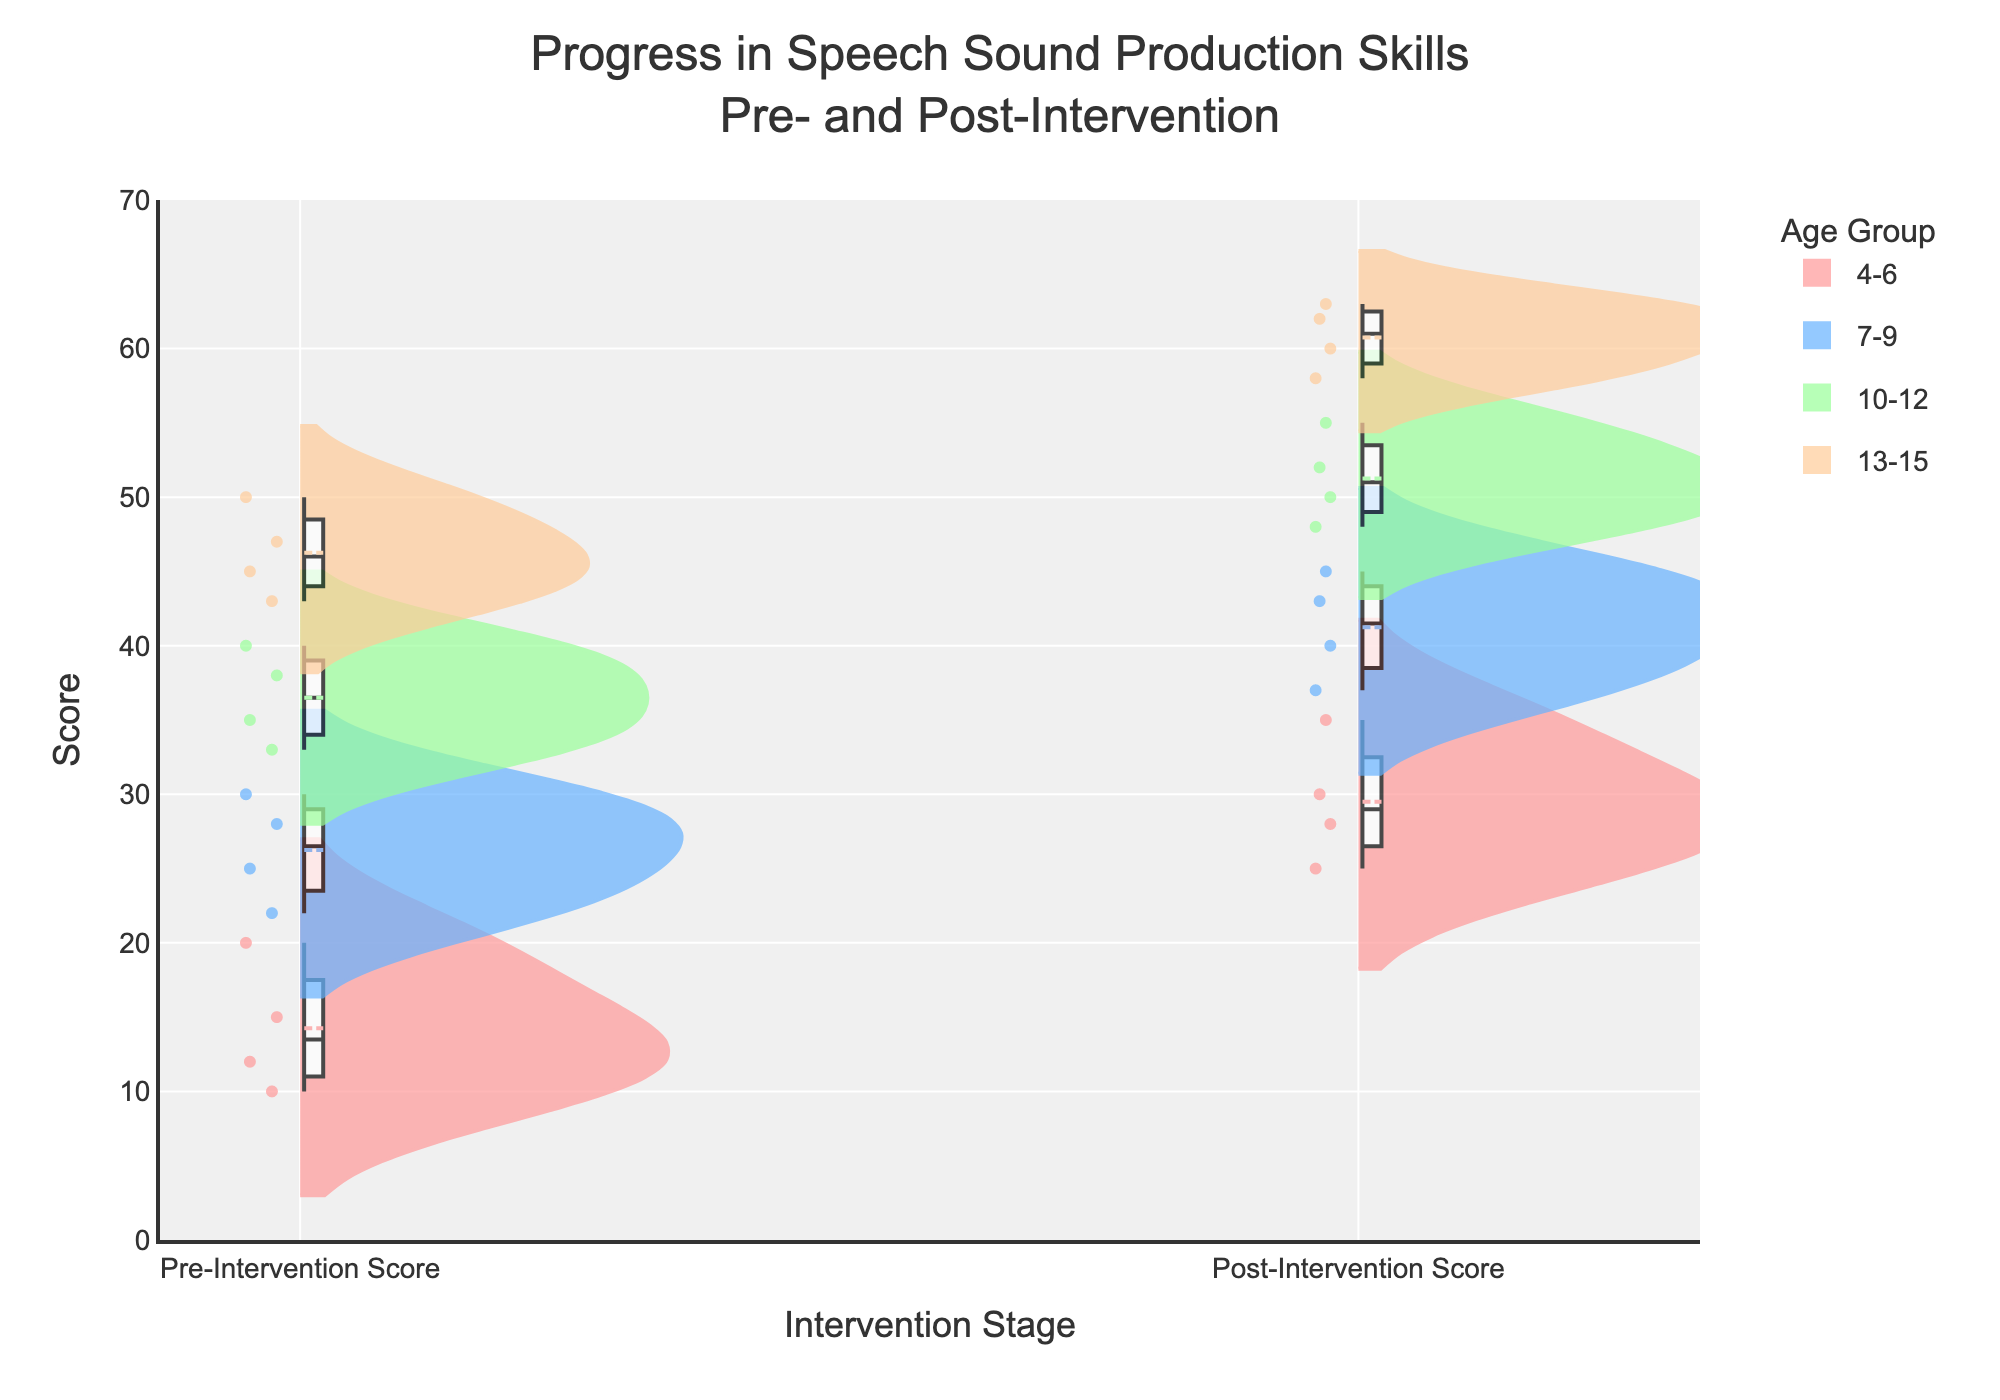What is the title of the figure? The title is typically displayed at the top of the figure. In this case, it is "Progress in Speech Sound Production Skills Pre- and Post-Intervention."
Answer: Progress in Speech Sound Production Skills Pre- and Post-Intervention Which age group shows the highest post-intervention score? By comparing the distribution of the post-intervention scores for each age group, the 13-15 age group shows the highest scores, reaching up to around 63.
Answer: 13-15 Are there more data points in the pre-intervention or post-intervention stage for the 7-9 age group? Count the number of points for each stage in the 7-9 age group. They have the same number of data points for both stages, as each student has both pre- and post-intervention scores.
Answer: Same What is the axis title for the y-axis? The y-axis title is generally positioned vertically along the y-axis. It reads "Score."
Answer: Score How do the pre-intervention scores compare among all age groups? Pre-intervention scores are generally lower across all groups compared to post-intervention scores, with the highest pre-intervention scores found in the 13-15 age group.
Answer: Lower compared to post-intervention Which age group showed the greatest range of improvement from pre- to post-intervention? To determine the range of improvement, compare the spread of scores from pre- to post-intervention for each age group. The 4-6 age group shows a significant gap, from scores near 10-15 to 25-30.
Answer: 4-6 What is the maximum score observed in the pre-intervention stage? Locate the highest point on the pre-intervention side of the violins. The maximum pre-intervention score is around 50 in the 13-15 age group.
Answer: 50 What color represents the 10-12 age group, and how does this help identify their scores? The 10-12 age group is depicted in blue. This helps distinguish their scores from other age groups both pre- and post-intervention.
Answer: Blue Which stage (pre- or post-intervention) generally has a wider spread of scores across all age groups? Observe the spread of the violins. Post-intervention scores generally have a wider spread, indicating more variation among student improvements.
Answer: Post-intervention How consistent are the improvements in speech production skills across different age groups? The consistency can be visualized by the extent of overlap and the width of the violins. Age groups 4-6 and 13-15 show more consistent improvements as indicated by less overlap.
Answer: More consistent in 4-6 and 13-15 Is there a noticeable difference in the mean scores pre- and post-intervention for any age group? The mean line visible in the violins can help identify this difference. All age groups show a noticeable increase in mean scores post-intervention.
Answer: Yes, for all age groups 